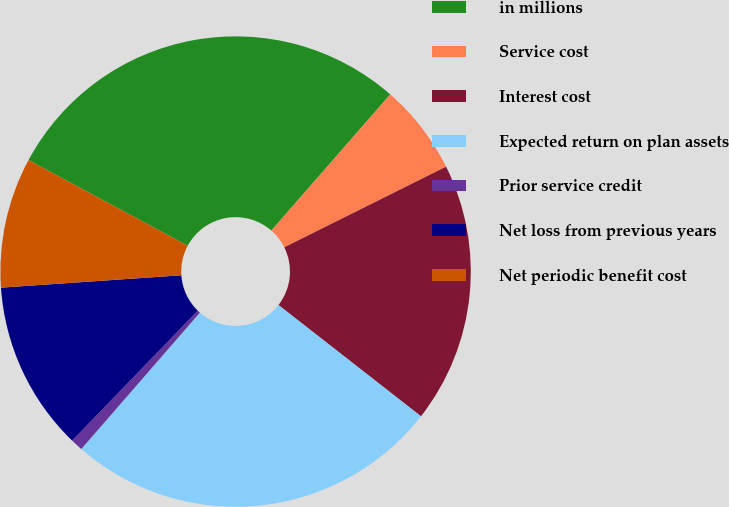Convert chart. <chart><loc_0><loc_0><loc_500><loc_500><pie_chart><fcel>in millions<fcel>Service cost<fcel>Interest cost<fcel>Expected return on plan assets<fcel>Prior service credit<fcel>Net loss from previous years<fcel>Net periodic benefit cost<nl><fcel>28.57%<fcel>6.22%<fcel>17.91%<fcel>25.84%<fcel>0.84%<fcel>11.68%<fcel>8.95%<nl></chart> 